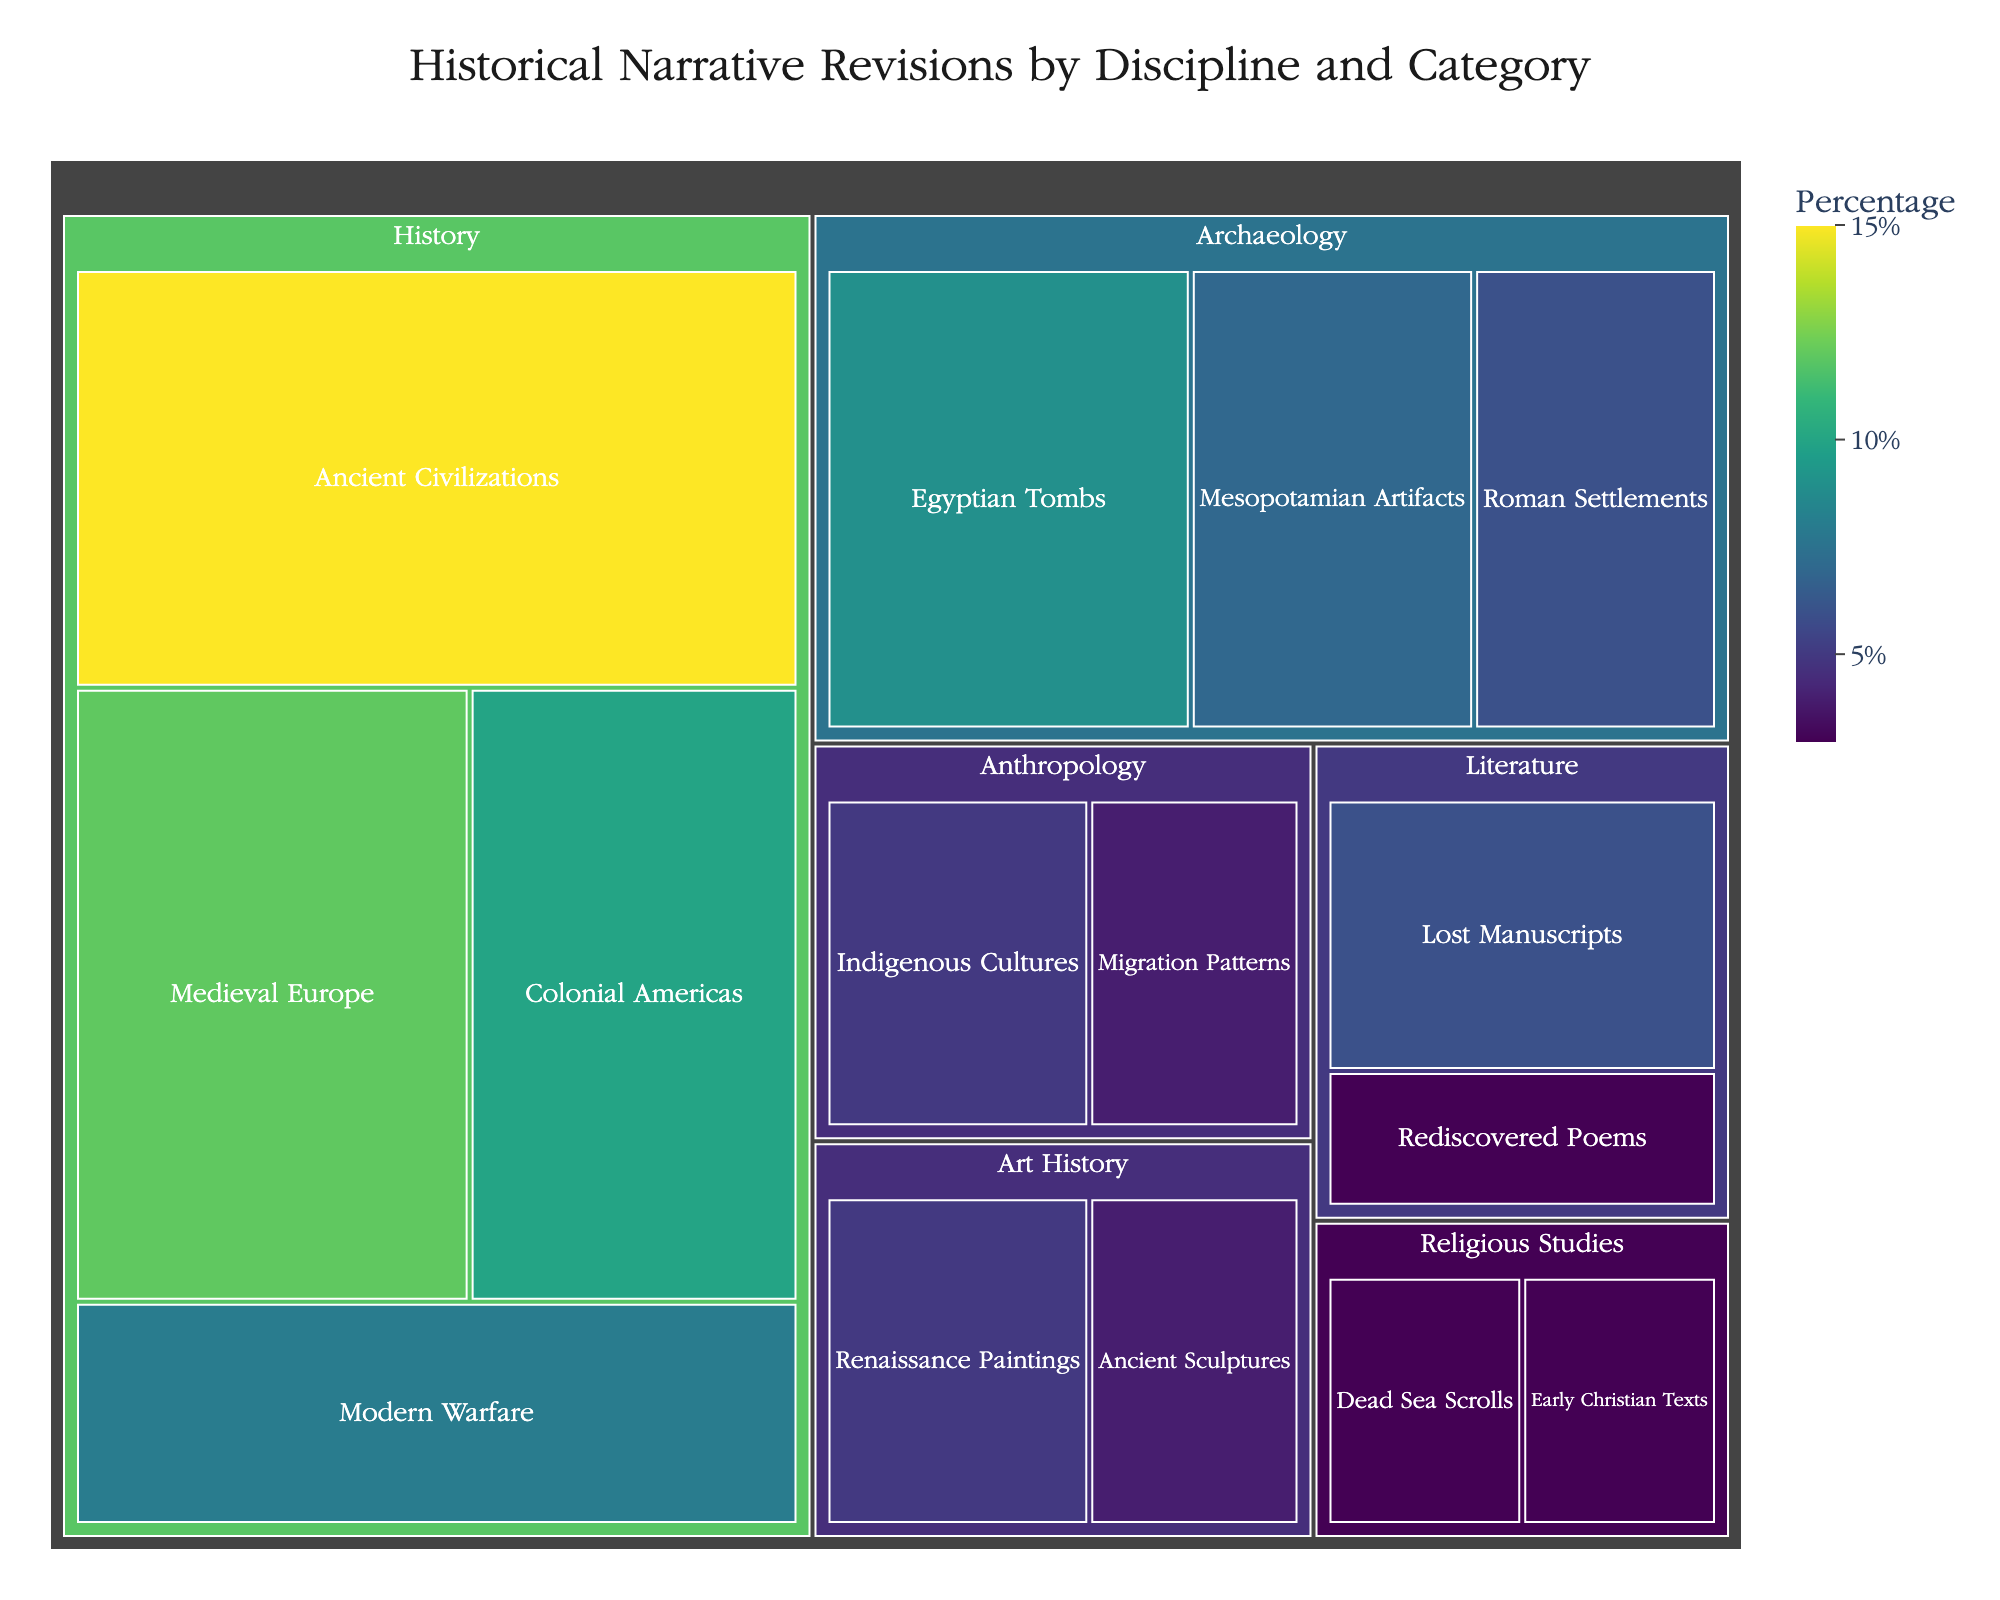What's the largest category in the treemap? To find the largest category, look for the segment with the biggest size. The "Ancient Civilizations" category in the "History" discipline appears to be the largest, with a percentage of 15%.
Answer: Ancient Civilizations What is the percentage contribution of the "History" discipline? Summing up all the categories under "History" (Ancient Civilizations, Medieval Europe, Modern Warfare, Colonial Americas) results in 15% + 12% + 8% + 10% = 45%.
Answer: 45% Which two disciplines have the smallest contribution and what are their percentages? The "Anthropology" discipline and "Religious Studies" discipline have the smallest contributions. Summing the categories under each: Anthropology has 5% + 4% = 9%, and Religious Studies has 3% + 3% = 6%.
Answer: Anthropology: 9%, Religious Studies: 6% Between "Archaeology" and "Art History," which discipline has a higher total percentage, and by how much? Summing the categories under "Archaeology" (Mesopotamian Artifacts, Egyptian Tombs, Roman Settlements) results in 7% + 9% + 6% = 22%. For "Art History" (Renaissance Paintings, Ancient Sculptures), it is 5% + 4% = 9%. "Archaeology" has a higher total by 22% - 9% = 13%.
Answer: Archaeology by 13% Which category in the "Literature" discipline has a smaller contribution and what is the percentage difference with the larger one? "Lost Manuscripts" and "Rediscovered Poems" are the two categories in "Literature." "Lost Manuscripts" has 6% and "Rediscovered Poems" has 3%. The difference is 6% - 3% = 3%.
Answer: Rediscovered Poems, 3% What is the difference in percentage between the highest and lowest contributing categories? The highest contributing category is "Ancient Civilizations" at 15%. The lowest contributing categories are several at 3%, like "Rediscovered Poems" and "Early Christian Texts". The difference is 15% - 3% = 12%.
Answer: 12% How many categories in total make up the given data? Count each category listed under every discipline: there are 16 categories in total.
Answer: 16 Which category in the "Archaeology" discipline has the largest percentage? In the "Archaeology" discipline, the largest percentage is "Egyptian Tombs" at 9%.
Answer: Egyptian Tombs What is the sum of percentages for all categories under "Religious Studies"? Summing the categories under "Religious Studies" (Dead Sea Scrolls, Early Christian Texts) results in 3% + 3% = 6%.
Answer: 6% Which discipline has more categories: "Literature" or "Religious Studies"? "Literature" has 2 categories (Lost Manuscripts, Rediscovered Poems) and "Religious Studies" also has 2 categories (Dead Sea Scrolls, Early Christian Texts). They have an equal number of categories.
Answer: Equal 